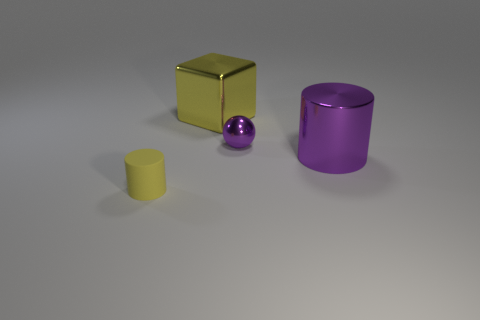What number of things are either large blue metal cylinders or purple objects?
Provide a succinct answer. 2. The metal cube that is the same size as the purple metal cylinder is what color?
Your answer should be very brief. Yellow. There is a cylinder behind the small cylinder; what number of tiny purple metal things are behind it?
Keep it short and to the point. 1. What number of objects are both in front of the purple metal sphere and right of the big yellow object?
Provide a succinct answer. 1. How many things are yellow matte cylinders that are left of the metal cube or things in front of the purple metal cylinder?
Your answer should be compact. 1. What shape is the tiny object that is in front of the big thing that is on the right side of the shiny cube?
Your answer should be compact. Cylinder. There is a cylinder that is to the left of the large metallic cylinder; is its color the same as the large shiny object behind the tiny ball?
Your answer should be very brief. Yes. What color is the rubber cylinder?
Your answer should be very brief. Yellow. Is there a purple metal object?
Ensure brevity in your answer.  Yes. There is a purple sphere; are there any metallic things behind it?
Offer a terse response. Yes. 